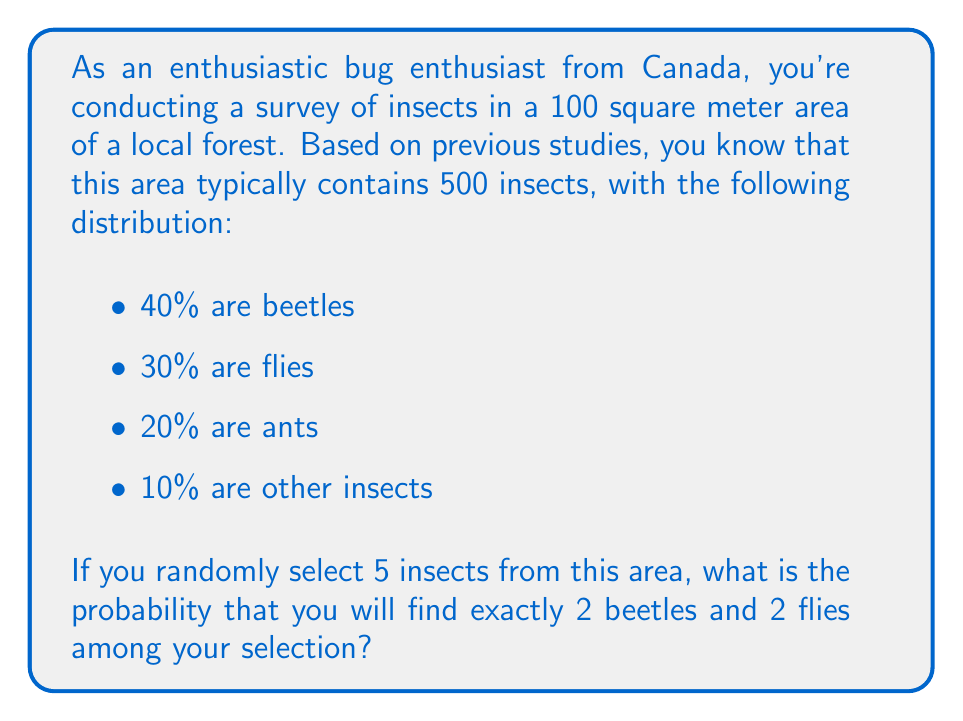Teach me how to tackle this problem. To solve this problem, we'll use the concept of multinomial probability. Here's a step-by-step approach:

1) First, we need to calculate the number of each type of insect:
   Beetles: $500 \times 0.40 = 200$
   Flies: $500 \times 0.30 = 150$
   Ants: $500 \times 0.20 = 100$
   Others: $500 \times 0.10 = 50$

2) The probability of selecting each type of insect is:
   P(Beetle) = $\frac{200}{500} = 0.4$
   P(Fly) = $\frac{150}{500} = 0.3$
   P(Ant or Other) = $\frac{100+50}{500} = 0.3$

3) We want to calculate the probability of selecting 2 beetles, 2 flies, and 1 other insect (ant or other) out of 5 selections. This follows a multinomial distribution.

4) The formula for multinomial probability is:

   $$P(X_1=x_1, X_2=x_2, ..., X_k=x_k) = \frac{n!}{x_1!x_2!...x_k!} p_1^{x_1} p_2^{x_2} ... p_k^{x_k}$$

   Where:
   $n$ is the total number of trials (5 in this case)
   $x_i$ is the number of successes for each category
   $p_i$ is the probability of success for each category

5) Plugging in our values:

   $$P(X_1=2, X_2=2, X_3=1) = \frac{5!}{2!2!1!} (0.4)^2 (0.3)^2 (0.3)^1$$

6) Calculating:
   $$= 10 \times 0.16 \times 0.09 \times 0.3 = 0.0432$$

Therefore, the probability of selecting exactly 2 beetles and 2 flies out of 5 random insects is 0.0432 or 4.32%.
Answer: $0.0432$ or $4.32\%$ 